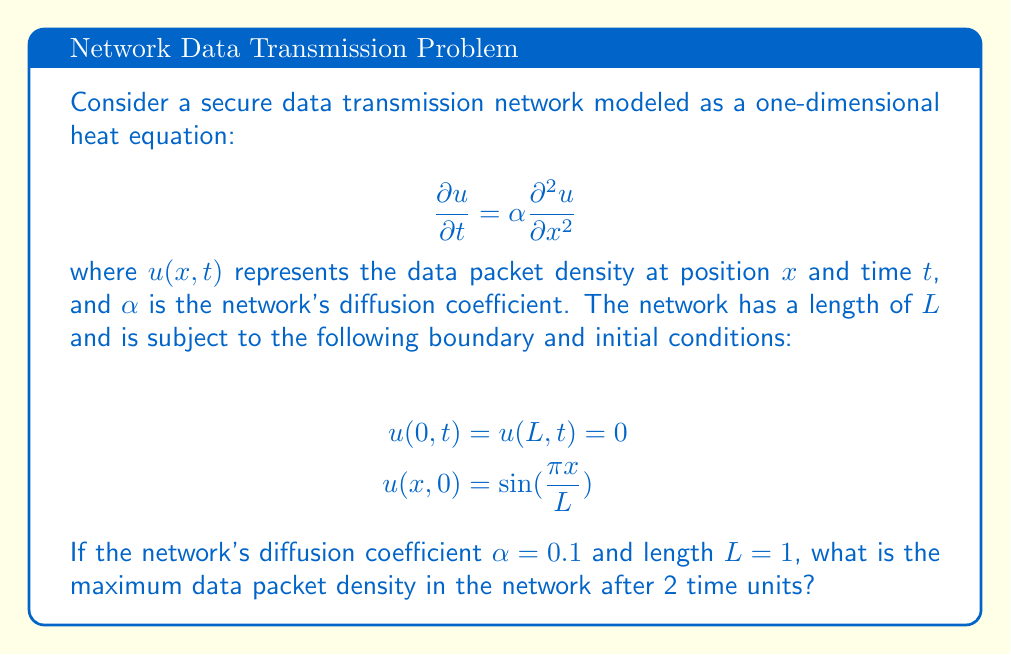Can you answer this question? To solve this problem, we'll use the method of separation of variables:

1) Assume a solution of the form $u(x,t) = X(x)T(t)$.

2) Substituting into the PDE and separating variables:

   $$\frac{T'(t)}{T(t)} = \alpha \frac{X''(x)}{X(x)} = -\lambda$$

3) Solving the spatial equation $X''(x) + \lambda X(x) = 0$ with boundary conditions:

   $$X(x) = \sin(\frac{n\pi x}{L}), \quad \lambda_n = (\frac{n\pi}{L})^2, \quad n = 1,2,3,...$$

4) Solving the temporal equation $T'(t) + \alpha\lambda_n T(t) = 0$:

   $$T(t) = e^{-\alpha\lambda_n t}$$

5) The general solution is:

   $$u(x,t) = \sum_{n=1}^{\infty} A_n \sin(\frac{n\pi x}{L}) e^{-\alpha(\frac{n\pi}{L})^2 t}$$

6) Using the initial condition to determine $A_n$:

   $$u(x,0) = \sin(\frac{\pi x}{L}) = \sum_{n=1}^{\infty} A_n \sin(\frac{n\pi x}{L})$$

   This implies $A_1 = 1$ and $A_n = 0$ for $n > 1$.

7) Therefore, the solution is:

   $$u(x,t) = \sin(\frac{\pi x}{L}) e^{-\alpha(\frac{\pi}{L})^2 t}$$

8) Substituting the given values ($\alpha = 0.1$, $L = 1$, $t = 2$):

   $$u(x,2) = \sin(\pi x) e^{-0.1\pi^2 \cdot 2} \approx 0.1616 \sin(\pi x)$$

9) The maximum value of $\sin(\pi x)$ is 1, occurring at $x = 0.5$.

10) Therefore, the maximum data packet density after 2 time units is approximately 0.1616.
Answer: 0.1616 